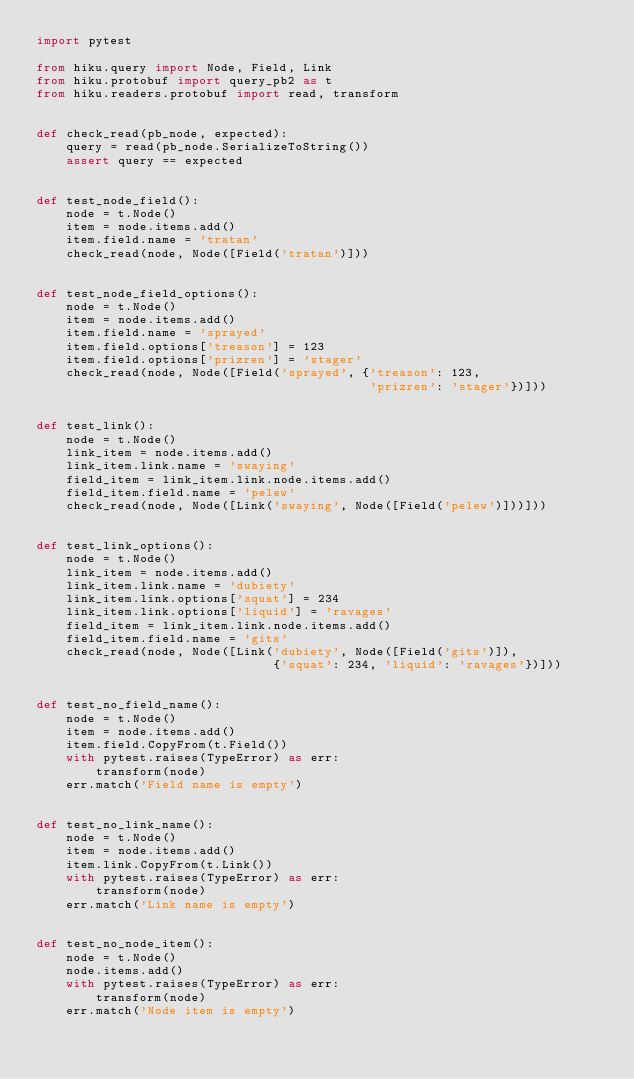Convert code to text. <code><loc_0><loc_0><loc_500><loc_500><_Python_>import pytest

from hiku.query import Node, Field, Link
from hiku.protobuf import query_pb2 as t
from hiku.readers.protobuf import read, transform


def check_read(pb_node, expected):
    query = read(pb_node.SerializeToString())
    assert query == expected


def test_node_field():
    node = t.Node()
    item = node.items.add()
    item.field.name = 'tratan'
    check_read(node, Node([Field('tratan')]))


def test_node_field_options():
    node = t.Node()
    item = node.items.add()
    item.field.name = 'sprayed'
    item.field.options['treason'] = 123
    item.field.options['prizren'] = 'stager'
    check_read(node, Node([Field('sprayed', {'treason': 123,
                                             'prizren': 'stager'})]))


def test_link():
    node = t.Node()
    link_item = node.items.add()
    link_item.link.name = 'swaying'
    field_item = link_item.link.node.items.add()
    field_item.field.name = 'pelew'
    check_read(node, Node([Link('swaying', Node([Field('pelew')]))]))


def test_link_options():
    node = t.Node()
    link_item = node.items.add()
    link_item.link.name = 'dubiety'
    link_item.link.options['squat'] = 234
    link_item.link.options['liquid'] = 'ravages'
    field_item = link_item.link.node.items.add()
    field_item.field.name = 'gits'
    check_read(node, Node([Link('dubiety', Node([Field('gits')]),
                                {'squat': 234, 'liquid': 'ravages'})]))


def test_no_field_name():
    node = t.Node()
    item = node.items.add()
    item.field.CopyFrom(t.Field())
    with pytest.raises(TypeError) as err:
        transform(node)
    err.match('Field name is empty')


def test_no_link_name():
    node = t.Node()
    item = node.items.add()
    item.link.CopyFrom(t.Link())
    with pytest.raises(TypeError) as err:
        transform(node)
    err.match('Link name is empty')


def test_no_node_item():
    node = t.Node()
    node.items.add()
    with pytest.raises(TypeError) as err:
        transform(node)
    err.match('Node item is empty')
</code> 